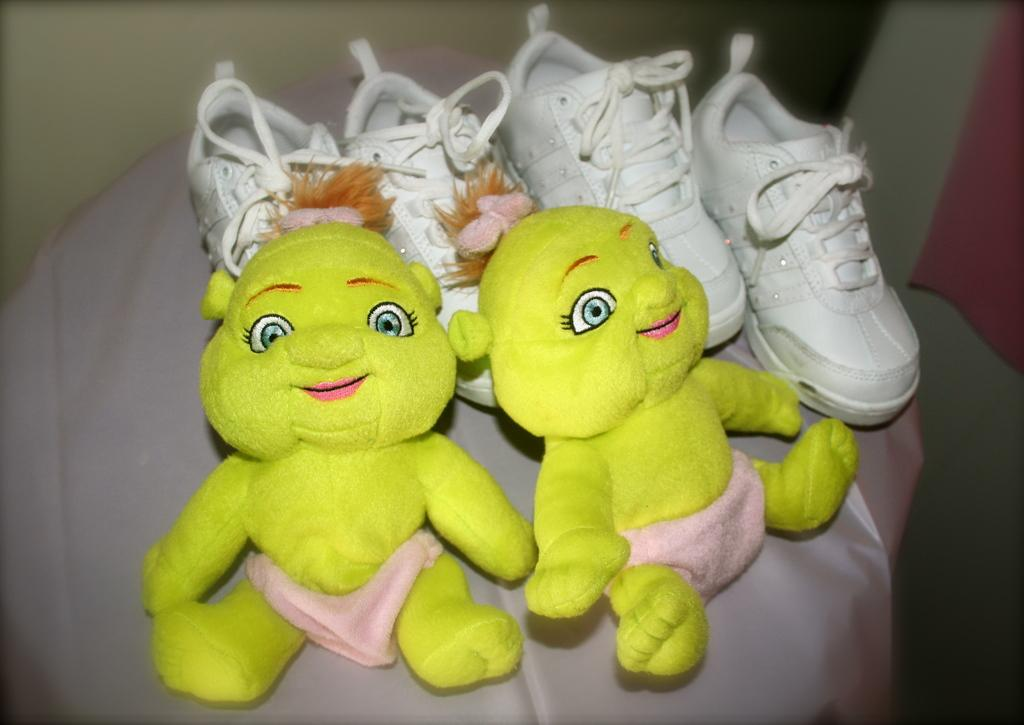What type of dolls can be seen in the image? There are two yellow dolls in the image. What color are the shoes in the image? The shoes in the image are white. How many pairs of shoes are present in the image? There are two pairs of white shoes in the image. On what surface are the shoes placed? The shoes are placed on a cloth. What country can be seen in the image? There is no country visible in the image; it is a still image of dolls and shoes placed on a cloth. 